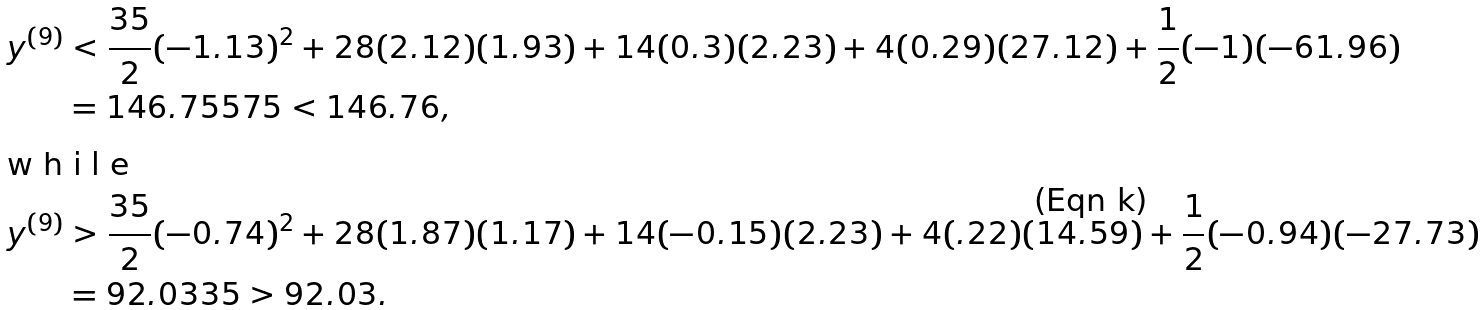Convert formula to latex. <formula><loc_0><loc_0><loc_500><loc_500>y ^ { ( 9 ) } & < \frac { 3 5 } { 2 } ( - 1 . 1 3 ) ^ { 2 } + 2 8 ( 2 . 1 2 ) ( 1 . 9 3 ) + 1 4 ( 0 . 3 ) ( 2 . 2 3 ) + 4 ( 0 . 2 9 ) ( 2 7 . 1 2 ) + \frac { 1 } { 2 } ( - 1 ) ( - 6 1 . 9 6 ) \\ & = 1 4 6 . 7 5 5 7 5 < 1 4 6 . 7 6 , \intertext { w h i l e } y ^ { ( 9 ) } & > \frac { 3 5 } { 2 } ( - 0 . 7 4 ) ^ { 2 } + 2 8 ( 1 . 8 7 ) ( 1 . 1 7 ) + 1 4 ( - 0 . 1 5 ) ( 2 . 2 3 ) + 4 ( . 2 2 ) ( 1 4 . 5 9 ) + \frac { 1 } { 2 } ( - 0 . 9 4 ) ( - 2 7 . 7 3 ) \\ & = 9 2 . 0 3 3 5 > 9 2 . 0 3 .</formula> 